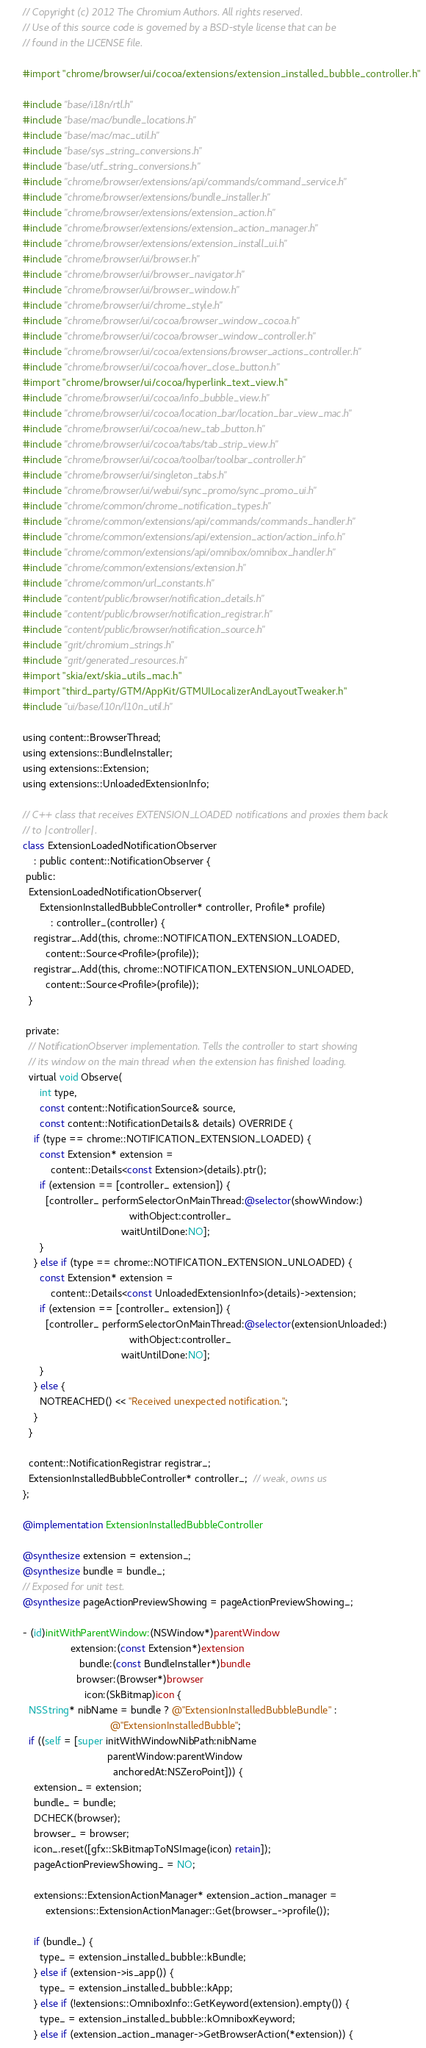Convert code to text. <code><loc_0><loc_0><loc_500><loc_500><_ObjectiveC_>// Copyright (c) 2012 The Chromium Authors. All rights reserved.
// Use of this source code is governed by a BSD-style license that can be
// found in the LICENSE file.

#import "chrome/browser/ui/cocoa/extensions/extension_installed_bubble_controller.h"

#include "base/i18n/rtl.h"
#include "base/mac/bundle_locations.h"
#include "base/mac/mac_util.h"
#include "base/sys_string_conversions.h"
#include "base/utf_string_conversions.h"
#include "chrome/browser/extensions/api/commands/command_service.h"
#include "chrome/browser/extensions/bundle_installer.h"
#include "chrome/browser/extensions/extension_action.h"
#include "chrome/browser/extensions/extension_action_manager.h"
#include "chrome/browser/extensions/extension_install_ui.h"
#include "chrome/browser/ui/browser.h"
#include "chrome/browser/ui/browser_navigator.h"
#include "chrome/browser/ui/browser_window.h"
#include "chrome/browser/ui/chrome_style.h"
#include "chrome/browser/ui/cocoa/browser_window_cocoa.h"
#include "chrome/browser/ui/cocoa/browser_window_controller.h"
#include "chrome/browser/ui/cocoa/extensions/browser_actions_controller.h"
#include "chrome/browser/ui/cocoa/hover_close_button.h"
#import "chrome/browser/ui/cocoa/hyperlink_text_view.h"
#include "chrome/browser/ui/cocoa/info_bubble_view.h"
#include "chrome/browser/ui/cocoa/location_bar/location_bar_view_mac.h"
#include "chrome/browser/ui/cocoa/new_tab_button.h"
#include "chrome/browser/ui/cocoa/tabs/tab_strip_view.h"
#include "chrome/browser/ui/cocoa/toolbar/toolbar_controller.h"
#include "chrome/browser/ui/singleton_tabs.h"
#include "chrome/browser/ui/webui/sync_promo/sync_promo_ui.h"
#include "chrome/common/chrome_notification_types.h"
#include "chrome/common/extensions/api/commands/commands_handler.h"
#include "chrome/common/extensions/api/extension_action/action_info.h"
#include "chrome/common/extensions/api/omnibox/omnibox_handler.h"
#include "chrome/common/extensions/extension.h"
#include "chrome/common/url_constants.h"
#include "content/public/browser/notification_details.h"
#include "content/public/browser/notification_registrar.h"
#include "content/public/browser/notification_source.h"
#include "grit/chromium_strings.h"
#include "grit/generated_resources.h"
#import "skia/ext/skia_utils_mac.h"
#import "third_party/GTM/AppKit/GTMUILocalizerAndLayoutTweaker.h"
#include "ui/base/l10n/l10n_util.h"

using content::BrowserThread;
using extensions::BundleInstaller;
using extensions::Extension;
using extensions::UnloadedExtensionInfo;

// C++ class that receives EXTENSION_LOADED notifications and proxies them back
// to |controller|.
class ExtensionLoadedNotificationObserver
    : public content::NotificationObserver {
 public:
  ExtensionLoadedNotificationObserver(
      ExtensionInstalledBubbleController* controller, Profile* profile)
          : controller_(controller) {
    registrar_.Add(this, chrome::NOTIFICATION_EXTENSION_LOADED,
        content::Source<Profile>(profile));
    registrar_.Add(this, chrome::NOTIFICATION_EXTENSION_UNLOADED,
        content::Source<Profile>(profile));
  }

 private:
  // NotificationObserver implementation. Tells the controller to start showing
  // its window on the main thread when the extension has finished loading.
  virtual void Observe(
      int type,
      const content::NotificationSource& source,
      const content::NotificationDetails& details) OVERRIDE {
    if (type == chrome::NOTIFICATION_EXTENSION_LOADED) {
      const Extension* extension =
          content::Details<const Extension>(details).ptr();
      if (extension == [controller_ extension]) {
        [controller_ performSelectorOnMainThread:@selector(showWindow:)
                                      withObject:controller_
                                   waitUntilDone:NO];
      }
    } else if (type == chrome::NOTIFICATION_EXTENSION_UNLOADED) {
      const Extension* extension =
          content::Details<const UnloadedExtensionInfo>(details)->extension;
      if (extension == [controller_ extension]) {
        [controller_ performSelectorOnMainThread:@selector(extensionUnloaded:)
                                      withObject:controller_
                                   waitUntilDone:NO];
      }
    } else {
      NOTREACHED() << "Received unexpected notification.";
    }
  }

  content::NotificationRegistrar registrar_;
  ExtensionInstalledBubbleController* controller_;  // weak, owns us
};

@implementation ExtensionInstalledBubbleController

@synthesize extension = extension_;
@synthesize bundle = bundle_;
// Exposed for unit test.
@synthesize pageActionPreviewShowing = pageActionPreviewShowing_;

- (id)initWithParentWindow:(NSWindow*)parentWindow
                 extension:(const Extension*)extension
                    bundle:(const BundleInstaller*)bundle
                   browser:(Browser*)browser
                      icon:(SkBitmap)icon {
  NSString* nibName = bundle ? @"ExtensionInstalledBubbleBundle" :
                               @"ExtensionInstalledBubble";
  if ((self = [super initWithWindowNibPath:nibName
                              parentWindow:parentWindow
                                anchoredAt:NSZeroPoint])) {
    extension_ = extension;
    bundle_ = bundle;
    DCHECK(browser);
    browser_ = browser;
    icon_.reset([gfx::SkBitmapToNSImage(icon) retain]);
    pageActionPreviewShowing_ = NO;

    extensions::ExtensionActionManager* extension_action_manager =
        extensions::ExtensionActionManager::Get(browser_->profile());

    if (bundle_) {
      type_ = extension_installed_bubble::kBundle;
    } else if (extension->is_app()) {
      type_ = extension_installed_bubble::kApp;
    } else if (!extensions::OmniboxInfo::GetKeyword(extension).empty()) {
      type_ = extension_installed_bubble::kOmniboxKeyword;
    } else if (extension_action_manager->GetBrowserAction(*extension)) {</code> 